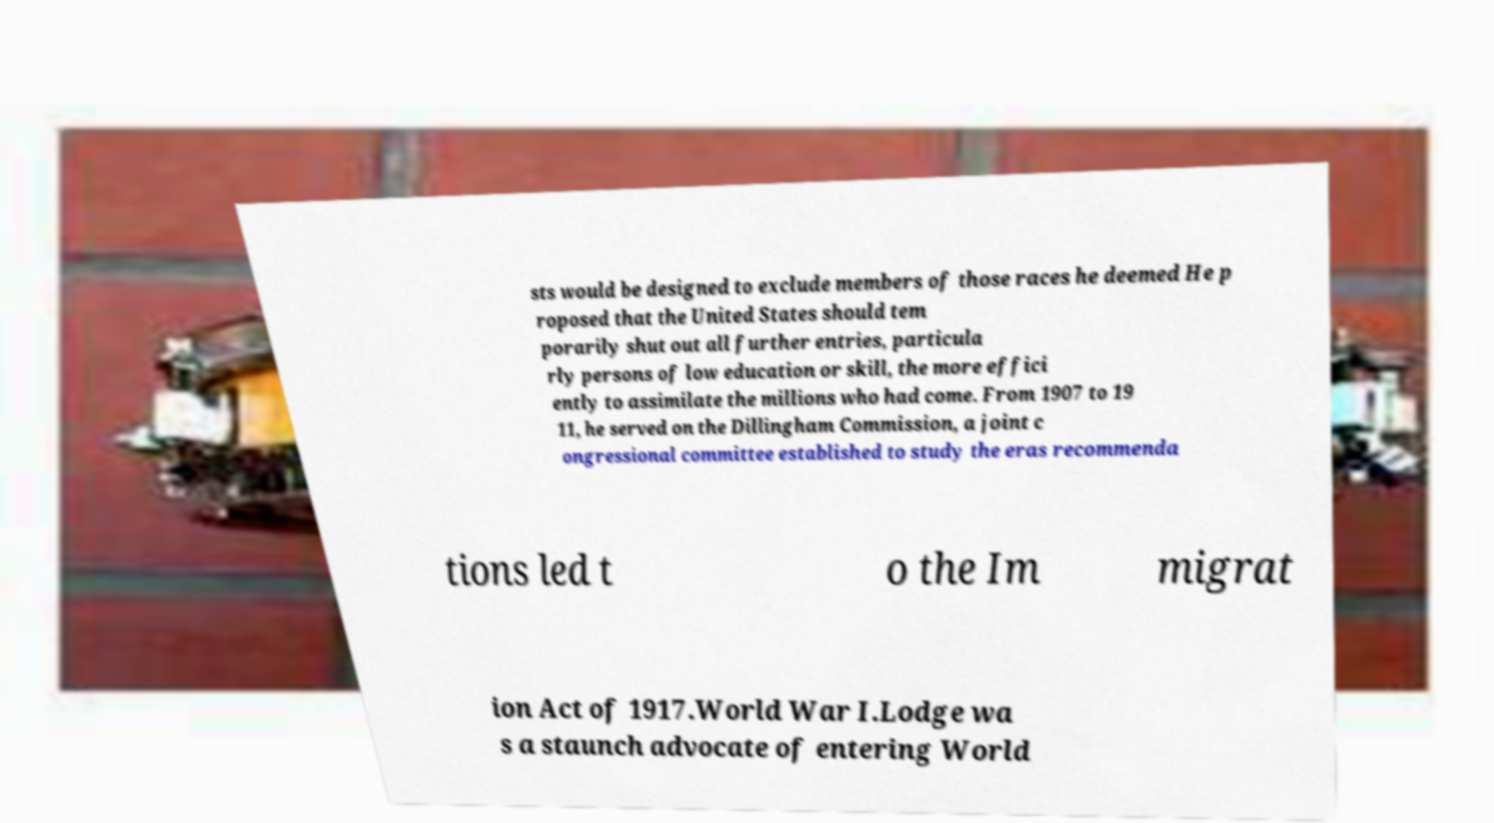I need the written content from this picture converted into text. Can you do that? sts would be designed to exclude members of those races he deemed He p roposed that the United States should tem porarily shut out all further entries, particula rly persons of low education or skill, the more effici ently to assimilate the millions who had come. From 1907 to 19 11, he served on the Dillingham Commission, a joint c ongressional committee established to study the eras recommenda tions led t o the Im migrat ion Act of 1917.World War I.Lodge wa s a staunch advocate of entering World 